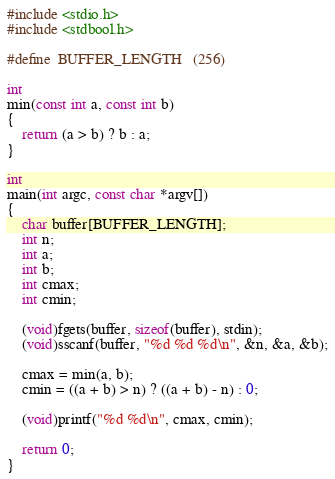Convert code to text. <code><loc_0><loc_0><loc_500><loc_500><_C_>#include <stdio.h>
#include <stdbool.h>

#define	BUFFER_LENGTH	(256)

int
min(const int a, const int b)
{
	return (a > b) ? b : a;
}

int
main(int argc, const char *argv[])
{
	char buffer[BUFFER_LENGTH];
	int n;
	int a;
	int b;
	int cmax;
	int cmin;

	(void)fgets(buffer, sizeof(buffer), stdin);
	(void)sscanf(buffer, "%d %d %d\n", &n, &a, &b);

	cmax = min(a, b);
	cmin = ((a + b) > n) ? ((a + b) - n) : 0;

	(void)printf("%d %d\n", cmax, cmin);

	return 0;
}
</code> 